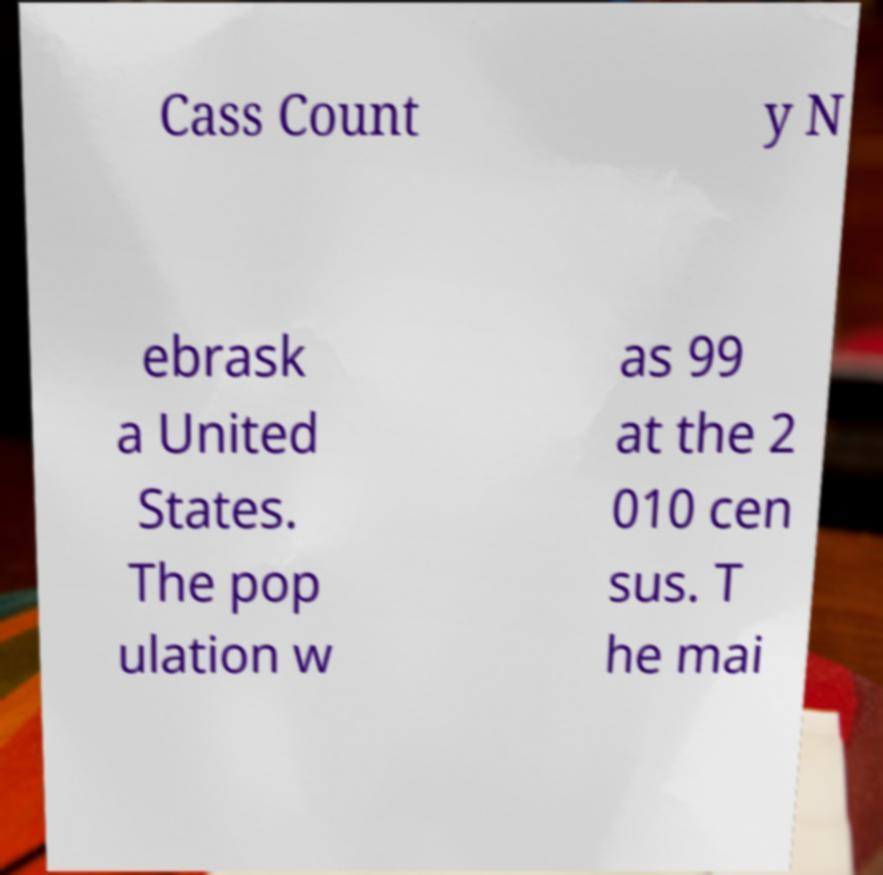For documentation purposes, I need the text within this image transcribed. Could you provide that? Cass Count y N ebrask a United States. The pop ulation w as 99 at the 2 010 cen sus. T he mai 